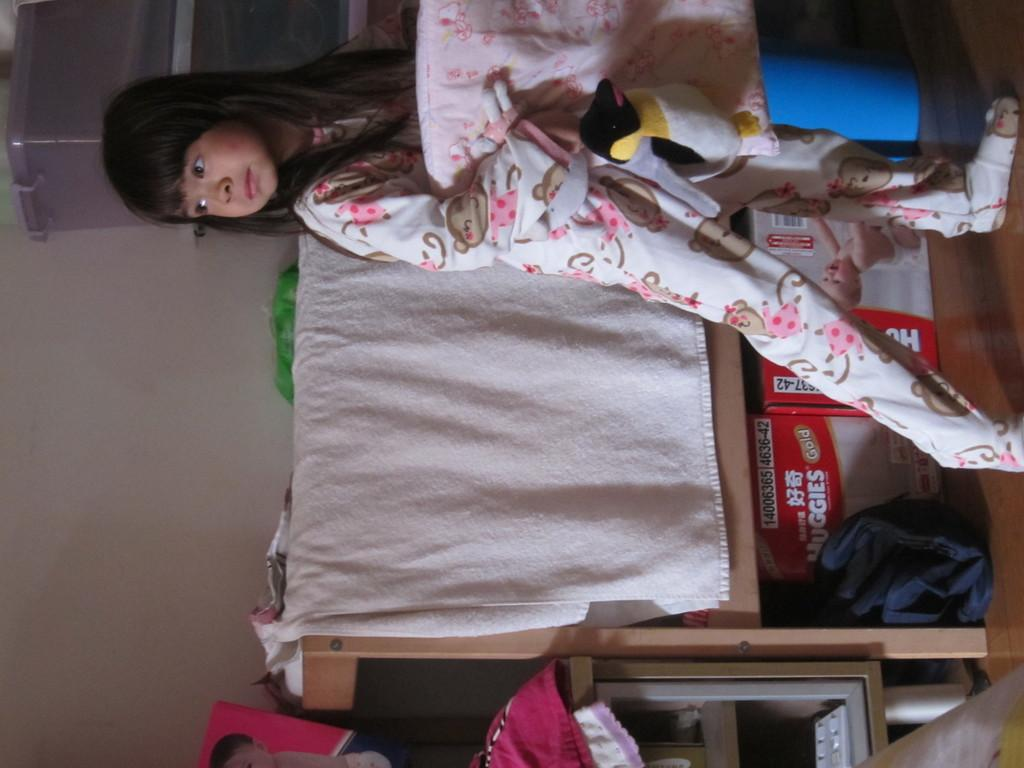Who is the main subject in the image? There is a girl in the image. What is the girl doing in the image? The girl is standing on the floor and holding a doll and a pillow in her hands. What else can be seen on the floor in the image? There are cardboard cartons on the floor. What is visible in the background of the image? There are objects arranged in the racks. What type of toothbrush is the girl using in the image? There is no toothbrush present in the image. What kind of plants can be seen growing in the racks? There are no plants visible in the image; only objects are arranged in the racks. 